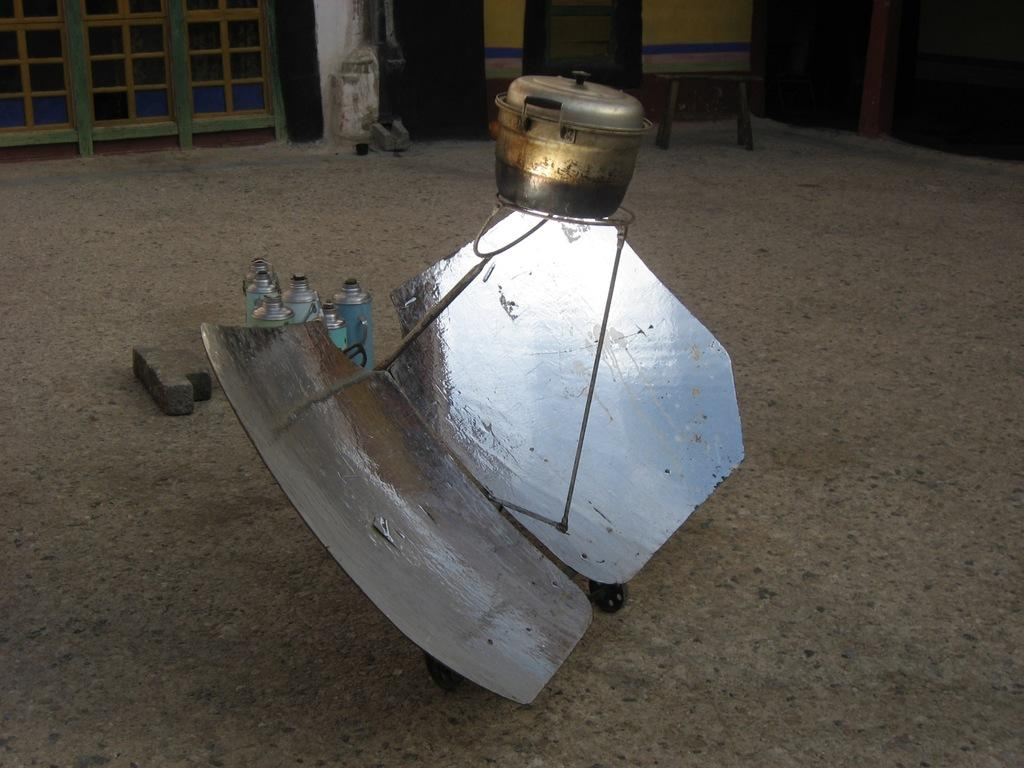What is located in the center of the picture? There are bottles, a brick, and an iron object in the center of the picture. What can be seen at the top of the picture? There are windows, a stool, and other wooden objects at the top of the picture. How does the brake work in the image? There is no brake present in the image. Can you describe the bath in the image? There is no bath present in the image. 